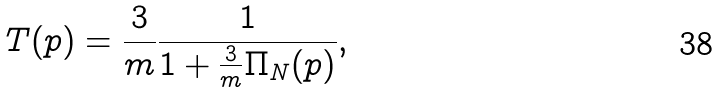Convert formula to latex. <formula><loc_0><loc_0><loc_500><loc_500>T ( p ) = \frac { 3 } { m } \frac { 1 } { 1 + \frac { 3 } { m } \Pi _ { N } ( p ) } ,</formula> 